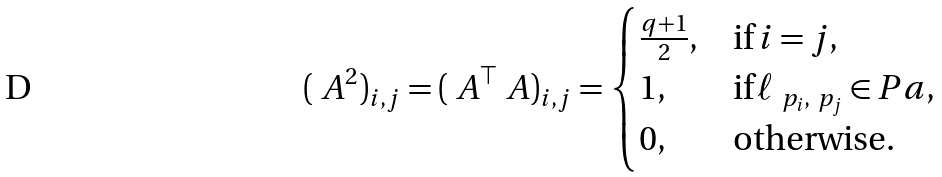<formula> <loc_0><loc_0><loc_500><loc_500>( \ A ^ { 2 } ) _ { i , j } = ( \ A ^ { \top } \ A ) _ { i , j } = \begin{cases} \frac { q + 1 } { 2 } , & \text {if} \, i = j , \\ 1 , & \text {if} \, \ell _ { \ p _ { i } , \ p _ { j } } \in P a , \\ 0 , & \text {otherwise} . \end{cases}</formula> 